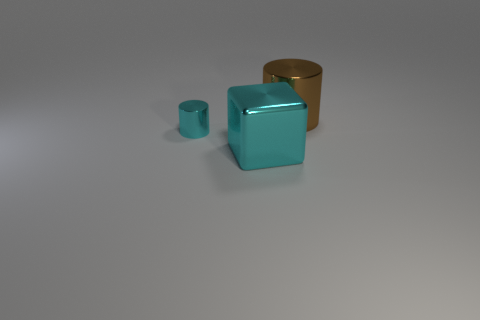Add 1 large brown things. How many objects exist? 4 Subtract all blocks. How many objects are left? 2 Add 2 metallic things. How many metallic things exist? 5 Subtract 0 brown cubes. How many objects are left? 3 Subtract all brown metallic cylinders. Subtract all cyan shiny things. How many objects are left? 0 Add 2 big metal objects. How many big metal objects are left? 4 